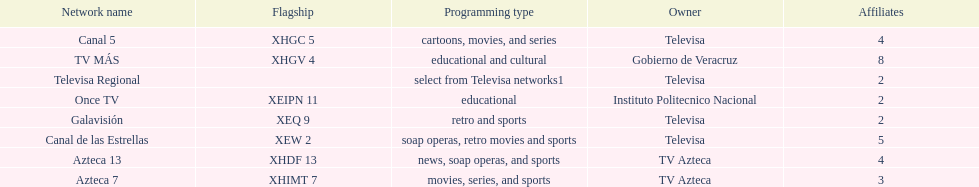Name each of tv azteca's network names. Azteca 7, Azteca 13. 